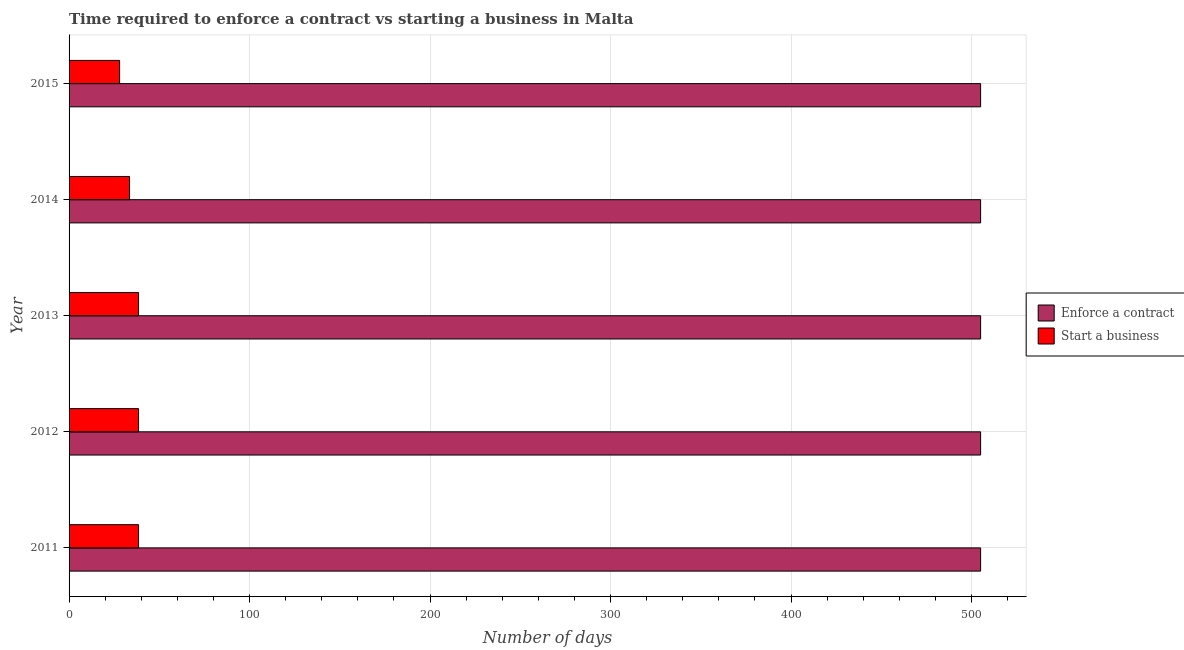How many different coloured bars are there?
Offer a terse response. 2. Are the number of bars per tick equal to the number of legend labels?
Provide a succinct answer. Yes. How many bars are there on the 1st tick from the top?
Give a very brief answer. 2. In how many cases, is the number of bars for a given year not equal to the number of legend labels?
Offer a very short reply. 0. What is the number of days to enforece a contract in 2012?
Make the answer very short. 505. Across all years, what is the maximum number of days to enforece a contract?
Offer a very short reply. 505. Across all years, what is the minimum number of days to start a business?
Provide a short and direct response. 28. In which year was the number of days to start a business minimum?
Offer a very short reply. 2015. What is the total number of days to enforece a contract in the graph?
Your answer should be very brief. 2525. What is the difference between the number of days to enforece a contract in 2015 and the number of days to start a business in 2013?
Offer a terse response. 466.5. What is the average number of days to start a business per year?
Offer a terse response. 35.4. In the year 2012, what is the difference between the number of days to start a business and number of days to enforece a contract?
Make the answer very short. -466.5. In how many years, is the number of days to enforece a contract greater than 160 days?
Offer a terse response. 5. What is the ratio of the number of days to enforece a contract in 2012 to that in 2013?
Offer a very short reply. 1. Is the number of days to enforece a contract in 2011 less than that in 2015?
Offer a very short reply. No. What is the difference between the highest and the second highest number of days to enforece a contract?
Your answer should be very brief. 0. What is the difference between the highest and the lowest number of days to enforece a contract?
Provide a succinct answer. 0. Is the sum of the number of days to start a business in 2013 and 2015 greater than the maximum number of days to enforece a contract across all years?
Your answer should be compact. No. What does the 2nd bar from the top in 2013 represents?
Your response must be concise. Enforce a contract. What does the 1st bar from the bottom in 2012 represents?
Your response must be concise. Enforce a contract. How many bars are there?
Offer a very short reply. 10. What is the difference between two consecutive major ticks on the X-axis?
Provide a succinct answer. 100. Are the values on the major ticks of X-axis written in scientific E-notation?
Your answer should be compact. No. How many legend labels are there?
Provide a short and direct response. 2. What is the title of the graph?
Keep it short and to the point. Time required to enforce a contract vs starting a business in Malta. Does "Male population" appear as one of the legend labels in the graph?
Make the answer very short. No. What is the label or title of the X-axis?
Offer a terse response. Number of days. What is the Number of days of Enforce a contract in 2011?
Ensure brevity in your answer.  505. What is the Number of days in Start a business in 2011?
Offer a terse response. 38.5. What is the Number of days in Enforce a contract in 2012?
Provide a succinct answer. 505. What is the Number of days of Start a business in 2012?
Provide a short and direct response. 38.5. What is the Number of days of Enforce a contract in 2013?
Make the answer very short. 505. What is the Number of days of Start a business in 2013?
Keep it short and to the point. 38.5. What is the Number of days in Enforce a contract in 2014?
Give a very brief answer. 505. What is the Number of days of Start a business in 2014?
Offer a terse response. 33.5. What is the Number of days of Enforce a contract in 2015?
Ensure brevity in your answer.  505. Across all years, what is the maximum Number of days in Enforce a contract?
Ensure brevity in your answer.  505. Across all years, what is the maximum Number of days in Start a business?
Provide a succinct answer. 38.5. Across all years, what is the minimum Number of days in Enforce a contract?
Make the answer very short. 505. What is the total Number of days of Enforce a contract in the graph?
Offer a terse response. 2525. What is the total Number of days in Start a business in the graph?
Give a very brief answer. 177. What is the difference between the Number of days in Enforce a contract in 2011 and that in 2013?
Give a very brief answer. 0. What is the difference between the Number of days in Start a business in 2011 and that in 2013?
Give a very brief answer. 0. What is the difference between the Number of days of Start a business in 2011 and that in 2015?
Your response must be concise. 10.5. What is the difference between the Number of days of Enforce a contract in 2012 and that in 2014?
Your answer should be compact. 0. What is the difference between the Number of days of Start a business in 2012 and that in 2014?
Your answer should be compact. 5. What is the difference between the Number of days in Enforce a contract in 2012 and that in 2015?
Your response must be concise. 0. What is the difference between the Number of days in Enforce a contract in 2013 and that in 2014?
Your answer should be compact. 0. What is the difference between the Number of days in Start a business in 2013 and that in 2014?
Your response must be concise. 5. What is the difference between the Number of days in Enforce a contract in 2013 and that in 2015?
Your answer should be very brief. 0. What is the difference between the Number of days in Start a business in 2013 and that in 2015?
Ensure brevity in your answer.  10.5. What is the difference between the Number of days in Enforce a contract in 2014 and that in 2015?
Make the answer very short. 0. What is the difference between the Number of days of Start a business in 2014 and that in 2015?
Keep it short and to the point. 5.5. What is the difference between the Number of days of Enforce a contract in 2011 and the Number of days of Start a business in 2012?
Provide a succinct answer. 466.5. What is the difference between the Number of days of Enforce a contract in 2011 and the Number of days of Start a business in 2013?
Offer a terse response. 466.5. What is the difference between the Number of days in Enforce a contract in 2011 and the Number of days in Start a business in 2014?
Your response must be concise. 471.5. What is the difference between the Number of days in Enforce a contract in 2011 and the Number of days in Start a business in 2015?
Your answer should be compact. 477. What is the difference between the Number of days of Enforce a contract in 2012 and the Number of days of Start a business in 2013?
Make the answer very short. 466.5. What is the difference between the Number of days in Enforce a contract in 2012 and the Number of days in Start a business in 2014?
Your answer should be compact. 471.5. What is the difference between the Number of days in Enforce a contract in 2012 and the Number of days in Start a business in 2015?
Offer a very short reply. 477. What is the difference between the Number of days of Enforce a contract in 2013 and the Number of days of Start a business in 2014?
Your answer should be very brief. 471.5. What is the difference between the Number of days of Enforce a contract in 2013 and the Number of days of Start a business in 2015?
Provide a short and direct response. 477. What is the difference between the Number of days in Enforce a contract in 2014 and the Number of days in Start a business in 2015?
Your answer should be very brief. 477. What is the average Number of days of Enforce a contract per year?
Offer a terse response. 505. What is the average Number of days in Start a business per year?
Your answer should be very brief. 35.4. In the year 2011, what is the difference between the Number of days of Enforce a contract and Number of days of Start a business?
Ensure brevity in your answer.  466.5. In the year 2012, what is the difference between the Number of days in Enforce a contract and Number of days in Start a business?
Provide a short and direct response. 466.5. In the year 2013, what is the difference between the Number of days of Enforce a contract and Number of days of Start a business?
Offer a very short reply. 466.5. In the year 2014, what is the difference between the Number of days of Enforce a contract and Number of days of Start a business?
Ensure brevity in your answer.  471.5. In the year 2015, what is the difference between the Number of days of Enforce a contract and Number of days of Start a business?
Your answer should be very brief. 477. What is the ratio of the Number of days in Enforce a contract in 2011 to that in 2012?
Your answer should be compact. 1. What is the ratio of the Number of days in Start a business in 2011 to that in 2014?
Offer a very short reply. 1.15. What is the ratio of the Number of days of Start a business in 2011 to that in 2015?
Provide a succinct answer. 1.38. What is the ratio of the Number of days of Enforce a contract in 2012 to that in 2013?
Offer a terse response. 1. What is the ratio of the Number of days in Start a business in 2012 to that in 2014?
Give a very brief answer. 1.15. What is the ratio of the Number of days of Start a business in 2012 to that in 2015?
Provide a succinct answer. 1.38. What is the ratio of the Number of days of Start a business in 2013 to that in 2014?
Your answer should be very brief. 1.15. What is the ratio of the Number of days in Enforce a contract in 2013 to that in 2015?
Your answer should be very brief. 1. What is the ratio of the Number of days of Start a business in 2013 to that in 2015?
Your answer should be very brief. 1.38. What is the ratio of the Number of days of Enforce a contract in 2014 to that in 2015?
Keep it short and to the point. 1. What is the ratio of the Number of days of Start a business in 2014 to that in 2015?
Your answer should be compact. 1.2. What is the difference between the highest and the lowest Number of days in Start a business?
Keep it short and to the point. 10.5. 